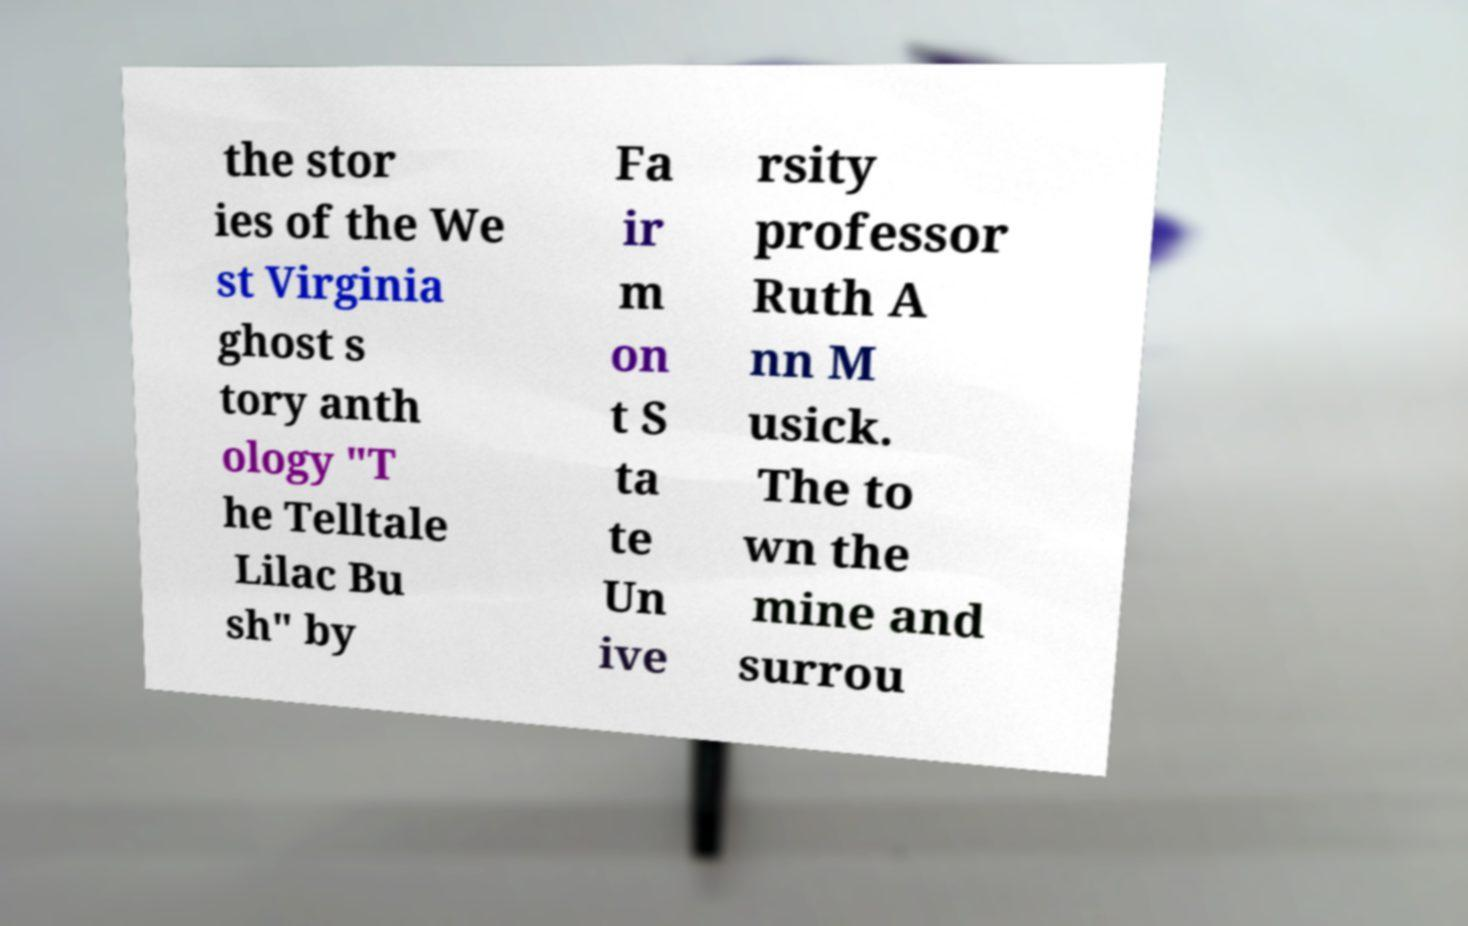For documentation purposes, I need the text within this image transcribed. Could you provide that? the stor ies of the We st Virginia ghost s tory anth ology "T he Telltale Lilac Bu sh" by Fa ir m on t S ta te Un ive rsity professor Ruth A nn M usick. The to wn the mine and surrou 